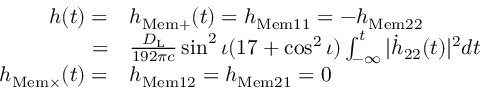<formula> <loc_0><loc_0><loc_500><loc_500>\begin{array} { r l } { h ( t ) = } & { h _ { M e m + } ( t ) = h _ { M e m 1 1 } = - h _ { M e m 2 2 } } \\ { = } & { \frac { D _ { L } } { 1 9 2 \pi c } \sin ^ { 2 } \iota ( 1 7 + \cos ^ { 2 } \iota ) \int _ { - \infty } ^ { t } | \dot { h } _ { 2 2 } ( t ) | ^ { 2 } d t } \\ { h _ { M e m \times } ( t ) = } & { h _ { M e m 1 2 } = h _ { M e m 2 1 } = 0 } \end{array}</formula> 